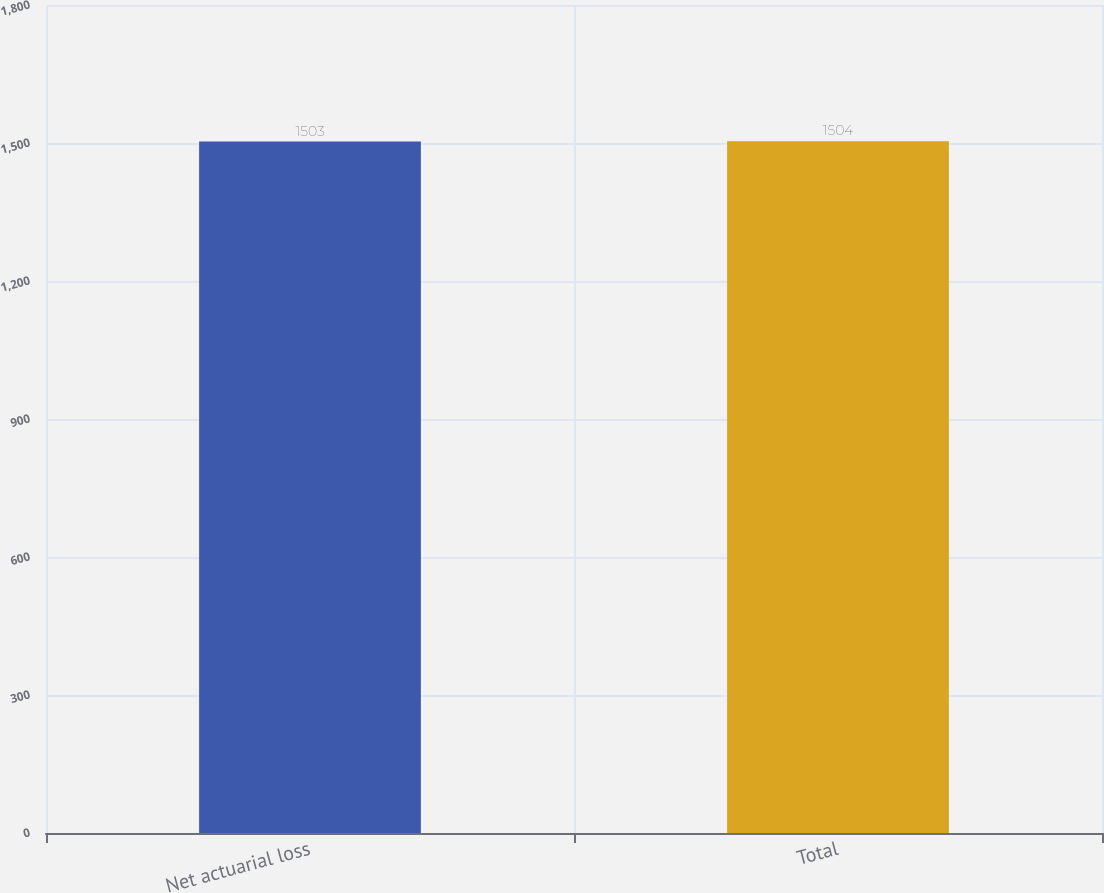<chart> <loc_0><loc_0><loc_500><loc_500><bar_chart><fcel>Net actuarial loss<fcel>Total<nl><fcel>1503<fcel>1504<nl></chart> 